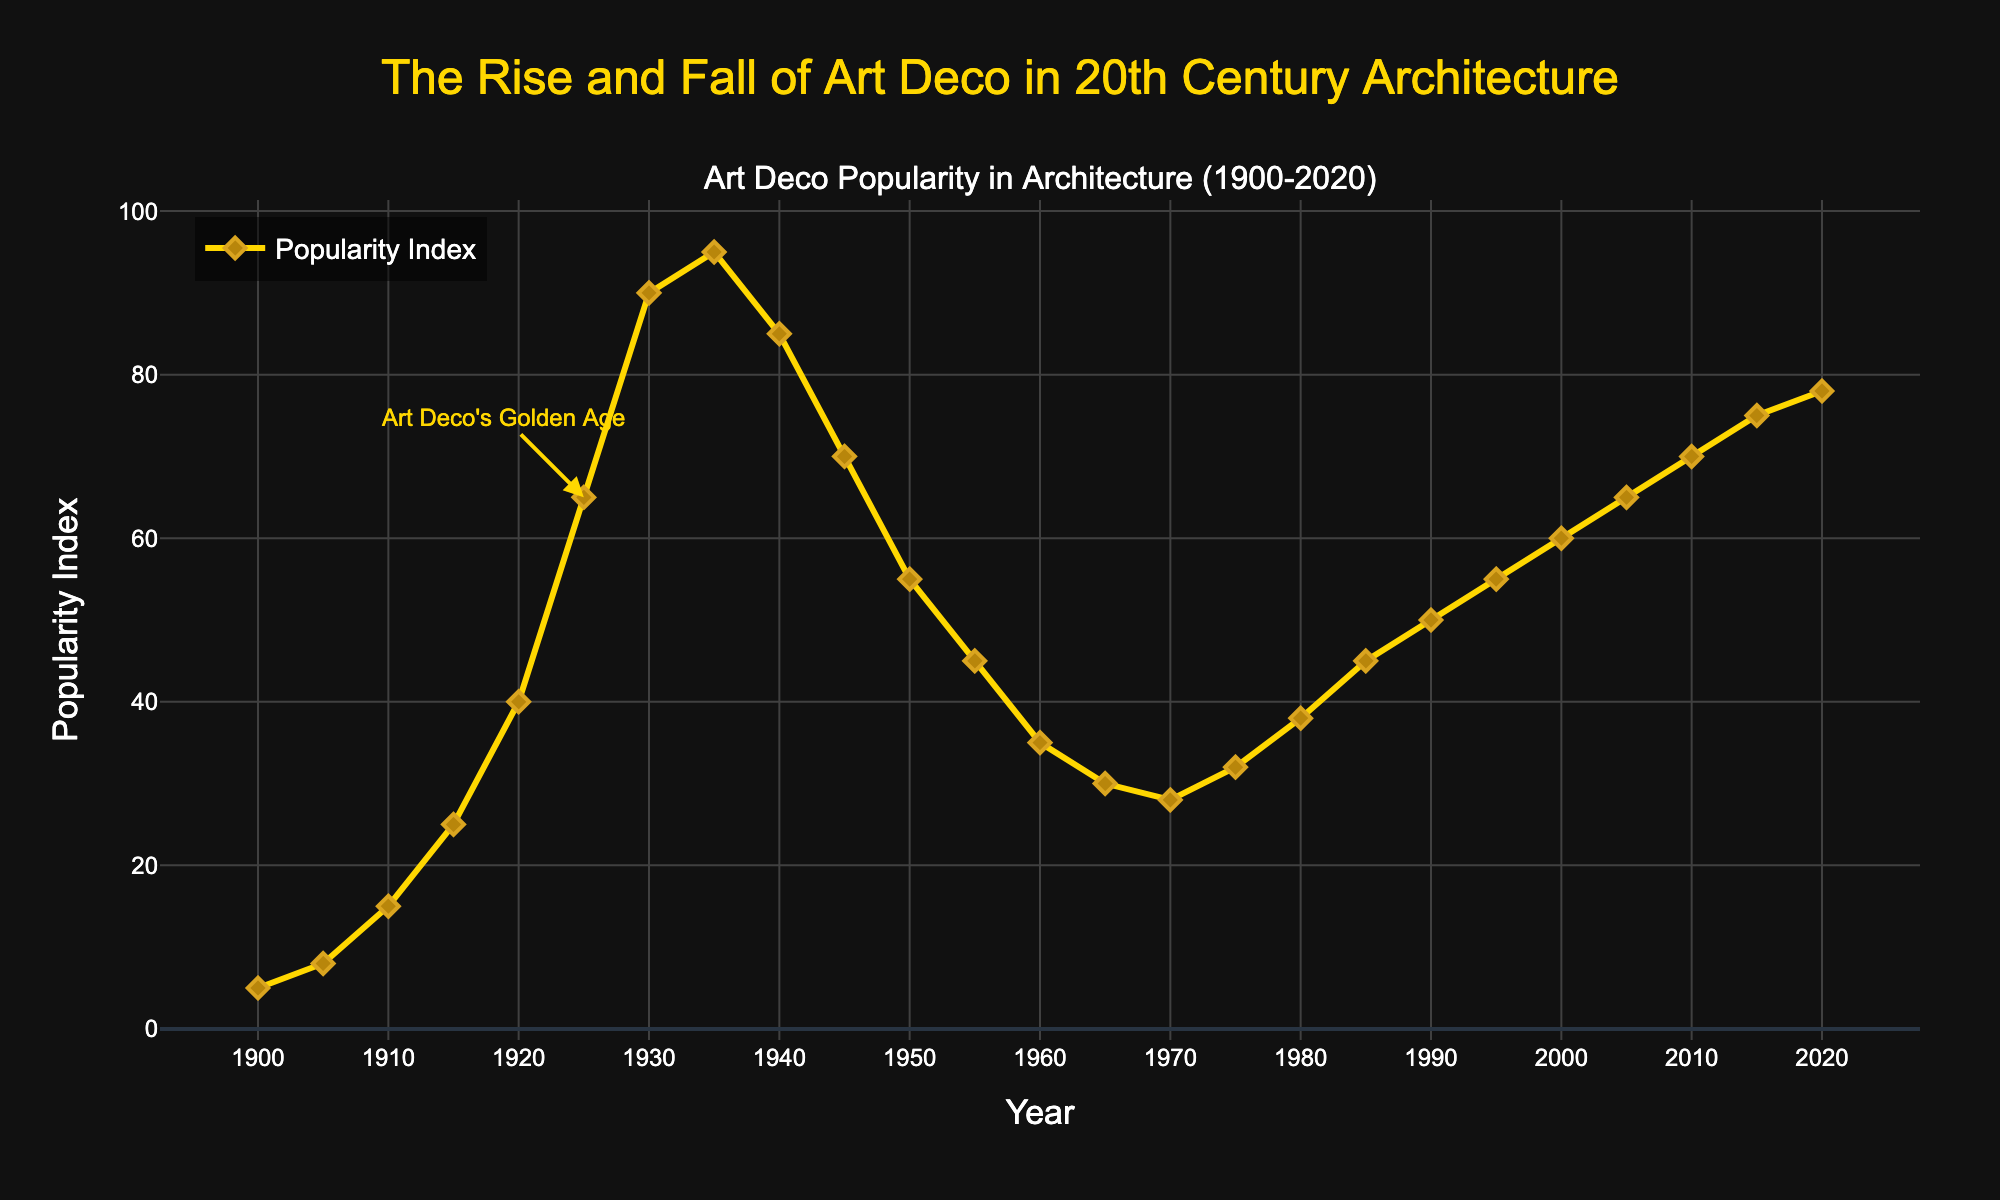What year did the popularity of Art Deco motifs peak? The peak is the highest point on the line chart. Look for the highest Popularity Index value, which occurs in 1935.
Answer: 1935 How much did the Popularity Index increase from 1920 to 1930? Find the Popularity Index values for 1920 and 1930, which are 40 and 90 respectively. Subtract 40 from 90 to get the increase.
Answer: 50 Which year saw the first decline in the Popularity Index after 1935? Check the line chart after 1935 for the first year with a lower Popularity Index than the previous year. The Popularity Index falls from 1935 to 1940.
Answer: 1940 Between which two decades was the most significant drop in popularity observed? Compare the differences in Popularity Index between each consecutive decade. The index drops the most from 1935 to 1955 (95 to 45).
Answer: 1935 to 1955 What is the average Popularity Index for the first half of the 20th century (1900-1950)? Add the Popularity Index values from 1900, 1905, 1910, 1915, 1920, 1925, 1930, 1935, 1940, 1945, and 1950, then divide by 11. (5 + 8 + 15 + 25 + 40 + 65 + 90 + 95 + 85 + 70 + 55) / 11 = 54.09
Answer: 54.09 Is the trend of Art Deco popularity more stable in the second half of the 20th century compared to the first half? Compare the fluctuations in the line for the periods 1900-1950 and 1950-2000. The second half (1950-2000) shows fewer and smaller fluctuations than the first half.
Answer: Yes Which period experienced a steady growth in popularity, lasting at least two decades? Search for a continuous upward trend in the line chart. Between 1980 and 2000, the index steadily increases from 38 to 60.
Answer: 1980 to 2000 What visual elements are used to highlight Art Deco's Golden Age? Look for annotations or special markers around the year 1925 on the chart. There's an annotation pointing to 1925 with the text "Art Deco's Golden Age" and an arrow.
Answer: Annotation with an arrow How much did the Popularity Index increase from 2000 to 2020? Find the Popularity Index values for 2000 and 2020, which are 60 and 78 respectively. Subtract 60 from 78 to get the increase.
Answer: 18 What is the highest recorded Popularity Index in the 21st century? Check the Popularity Index values for the years from 2000 onward. The highest value is 78 in 2020.
Answer: 78 